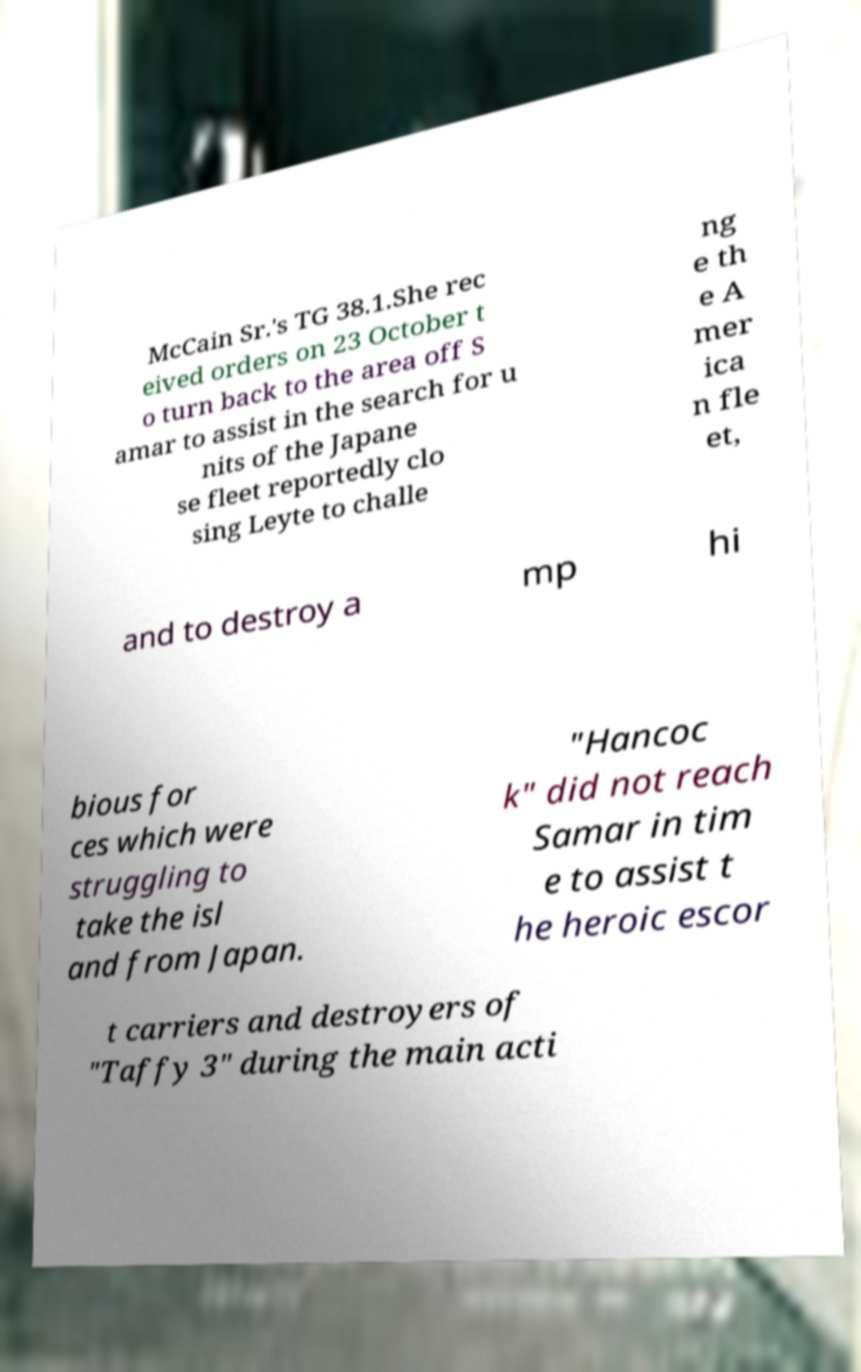Can you accurately transcribe the text from the provided image for me? McCain Sr.'s TG 38.1.She rec eived orders on 23 October t o turn back to the area off S amar to assist in the search for u nits of the Japane se fleet reportedly clo sing Leyte to challe ng e th e A mer ica n fle et, and to destroy a mp hi bious for ces which were struggling to take the isl and from Japan. "Hancoc k" did not reach Samar in tim e to assist t he heroic escor t carriers and destroyers of "Taffy 3" during the main acti 